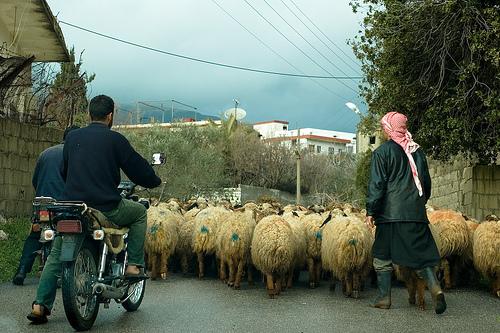How many motorcycles are there?
Answer briefly. 2. Where is a green painted spot?
Quick response, please. Sheep. Are there any telephone wires?
Keep it brief. Yes. 